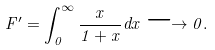<formula> <loc_0><loc_0><loc_500><loc_500>F ^ { \prime } = \int _ { 0 } ^ { \infty } \frac { x } { 1 + x } d x \longrightarrow 0 .</formula> 